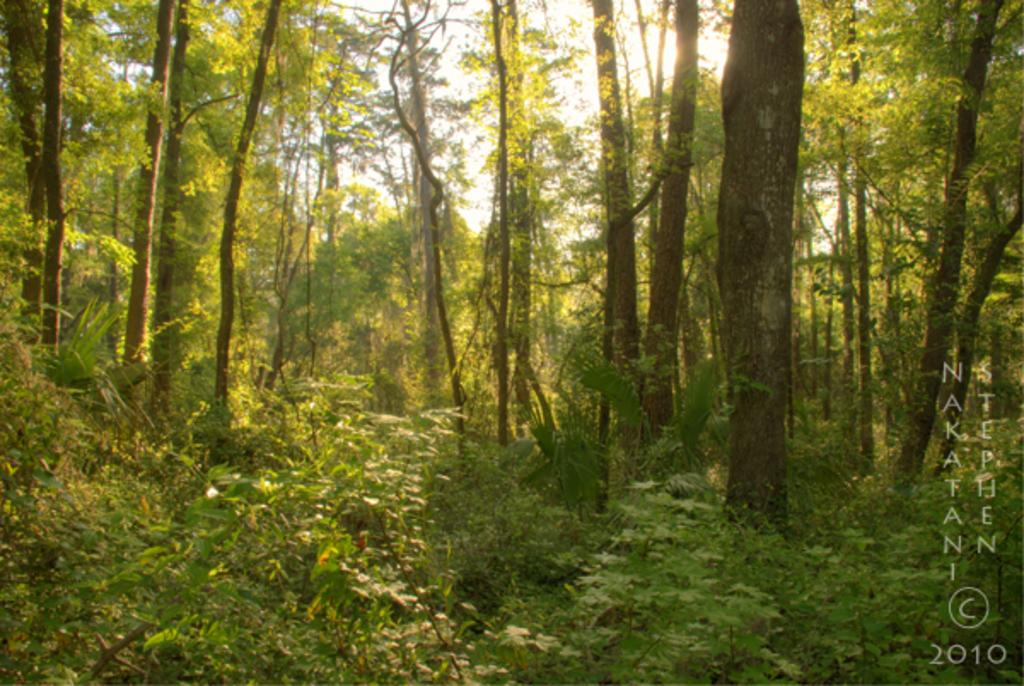What type of vegetation is present on the ground in the image? There are plants on the ground in the image. What other type of vegetation can be seen in the image? There are many trees in the image. What type of support can be seen for the fifth tree in the image? There is no mention of a fifth tree in the image, and no support is visible for any tree. 